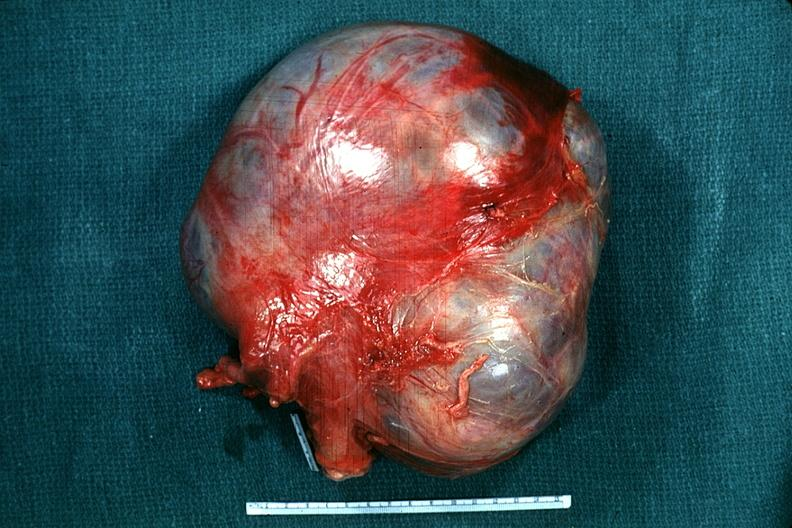what is present?
Answer the question using a single word or phrase. External view typical appearance but no tissue recognizable as ovary 